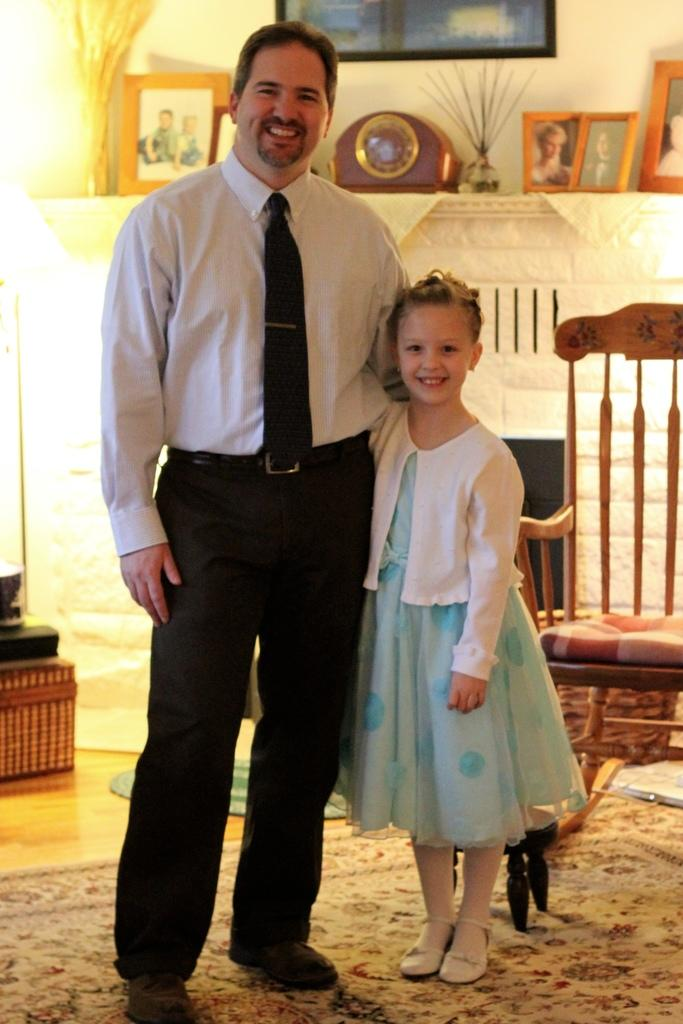Who are the people in the image? There is a man and a girl in the image. What expressions do the man and the girl have? Both the man and the girl are smiling in the image. What can be seen in the background of the image? There is a chair, photo frames on the wall, and a wall visible in the background of the image. What is the taste of the milk in the image? There is no milk present in the image, so it is not possible to determine its taste. 